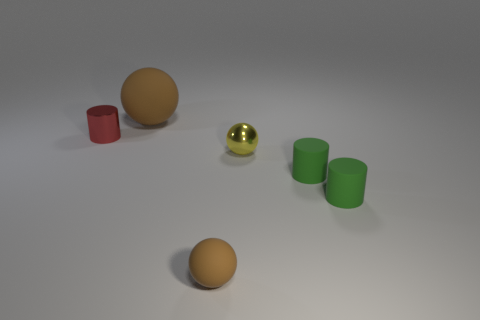Are there any green objects that have the same material as the large brown sphere?
Give a very brief answer. Yes. What size is the other thing that is the same color as the large object?
Offer a very short reply. Small. Is the number of small spheres less than the number of cylinders?
Your response must be concise. Yes. Do the small ball that is to the left of the small yellow metallic ball and the large matte object have the same color?
Your answer should be compact. Yes. There is a small ball that is left of the small shiny thing that is in front of the cylinder behind the yellow metallic object; what is it made of?
Keep it short and to the point. Rubber. Are there any big metal blocks that have the same color as the large rubber sphere?
Your answer should be very brief. No. Is the number of large objects on the right side of the small yellow sphere less than the number of shiny cylinders?
Ensure brevity in your answer.  Yes. Is the size of the brown thing in front of the yellow sphere the same as the big rubber sphere?
Your answer should be very brief. No. What number of things are both on the left side of the small yellow sphere and in front of the tiny red metallic thing?
Keep it short and to the point. 1. There is a brown rubber sphere to the left of the brown thing on the right side of the large brown matte ball; what is its size?
Provide a short and direct response. Large. 